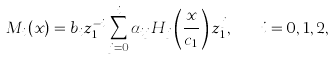Convert formula to latex. <formula><loc_0><loc_0><loc_500><loc_500>M _ { i } ( x ) = b _ { i } z _ { 1 } ^ { - i } \sum _ { j = 0 } ^ { i } \alpha _ { i j } H _ { j } \left ( \frac { x } { c _ { 1 } } \right ) z _ { 1 } ^ { j } , \quad i = 0 , 1 , 2 , \cdots</formula> 